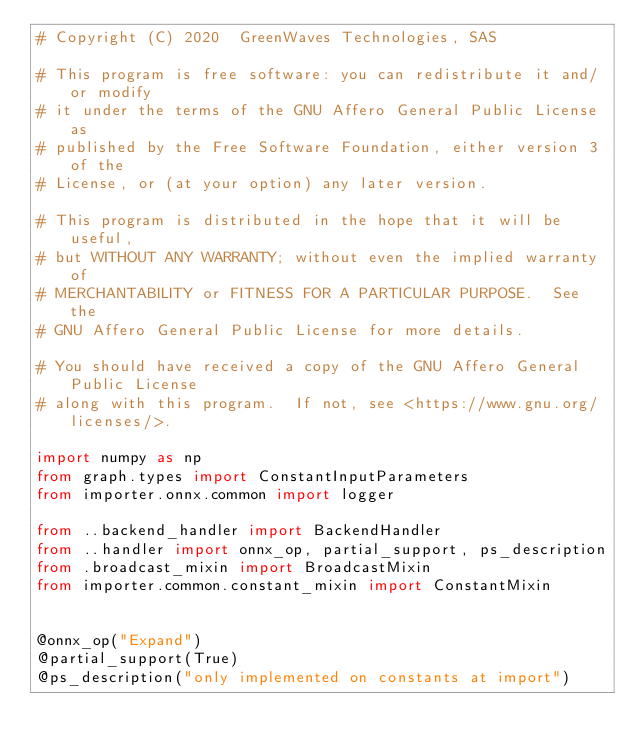Convert code to text. <code><loc_0><loc_0><loc_500><loc_500><_Python_># Copyright (C) 2020  GreenWaves Technologies, SAS

# This program is free software: you can redistribute it and/or modify
# it under the terms of the GNU Affero General Public License as
# published by the Free Software Foundation, either version 3 of the
# License, or (at your option) any later version.

# This program is distributed in the hope that it will be useful,
# but WITHOUT ANY WARRANTY; without even the implied warranty of
# MERCHANTABILITY or FITNESS FOR A PARTICULAR PURPOSE.  See the
# GNU Affero General Public License for more details.

# You should have received a copy of the GNU Affero General Public License
# along with this program.  If not, see <https://www.gnu.org/licenses/>.

import numpy as np
from graph.types import ConstantInputParameters
from importer.onnx.common import logger

from ..backend_handler import BackendHandler
from ..handler import onnx_op, partial_support, ps_description
from .broadcast_mixin import BroadcastMixin
from importer.common.constant_mixin import ConstantMixin


@onnx_op("Expand")
@partial_support(True)
@ps_description("only implemented on constants at import")</code> 